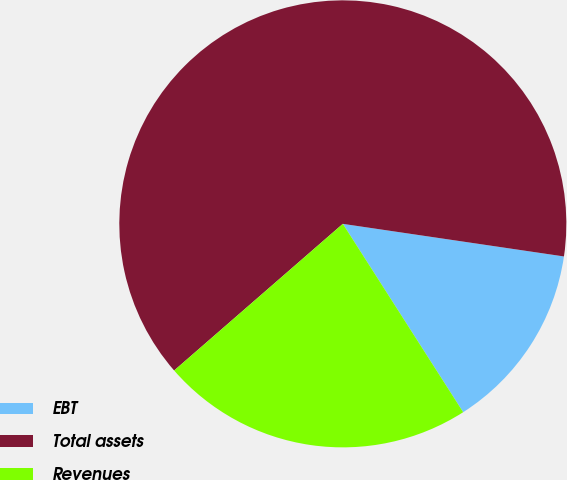Convert chart. <chart><loc_0><loc_0><loc_500><loc_500><pie_chart><fcel>EBT<fcel>Total assets<fcel>Revenues<nl><fcel>13.62%<fcel>63.72%<fcel>22.66%<nl></chart> 